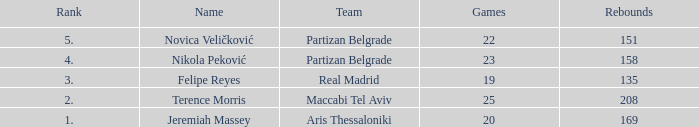How many Rebounds did Novica Veličković get in less than 22 Games? None. 